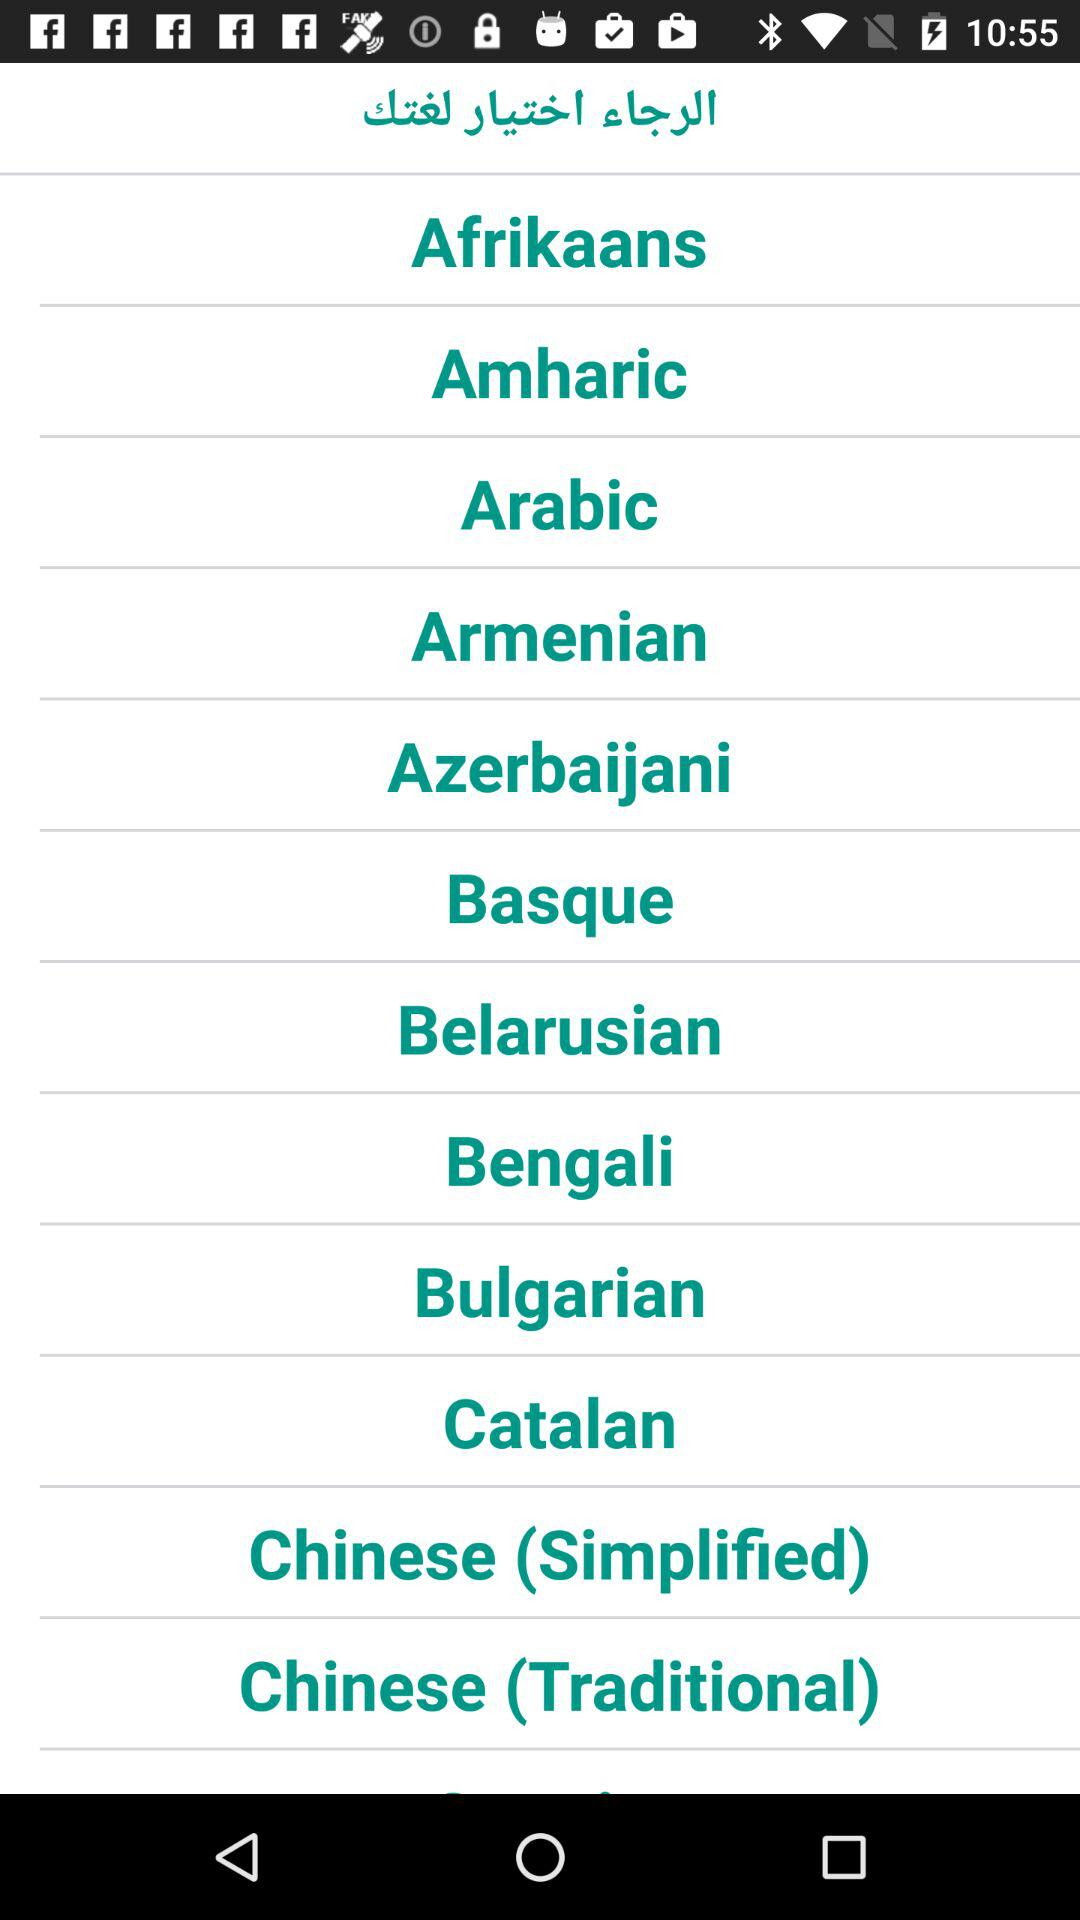What are the types of Chinese language? The types are simplified and traditional. 